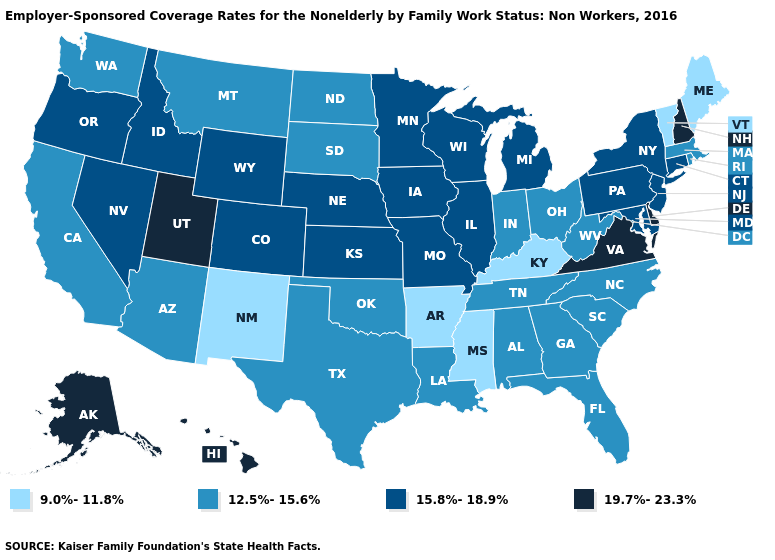Does Illinois have the same value as Wisconsin?
Keep it brief. Yes. Name the states that have a value in the range 12.5%-15.6%?
Write a very short answer. Alabama, Arizona, California, Florida, Georgia, Indiana, Louisiana, Massachusetts, Montana, North Carolina, North Dakota, Ohio, Oklahoma, Rhode Island, South Carolina, South Dakota, Tennessee, Texas, Washington, West Virginia. Name the states that have a value in the range 15.8%-18.9%?
Short answer required. Colorado, Connecticut, Idaho, Illinois, Iowa, Kansas, Maryland, Michigan, Minnesota, Missouri, Nebraska, Nevada, New Jersey, New York, Oregon, Pennsylvania, Wisconsin, Wyoming. Which states hav the highest value in the MidWest?
Give a very brief answer. Illinois, Iowa, Kansas, Michigan, Minnesota, Missouri, Nebraska, Wisconsin. What is the lowest value in the USA?
Quick response, please. 9.0%-11.8%. What is the value of Washington?
Short answer required. 12.5%-15.6%. Which states have the lowest value in the Northeast?
Answer briefly. Maine, Vermont. What is the value of North Carolina?
Be succinct. 12.5%-15.6%. Name the states that have a value in the range 9.0%-11.8%?
Give a very brief answer. Arkansas, Kentucky, Maine, Mississippi, New Mexico, Vermont. Among the states that border Nevada , does Utah have the highest value?
Write a very short answer. Yes. What is the lowest value in states that border Utah?
Write a very short answer. 9.0%-11.8%. Does the map have missing data?
Be succinct. No. What is the lowest value in the USA?
Concise answer only. 9.0%-11.8%. What is the value of Pennsylvania?
Short answer required. 15.8%-18.9%. Which states have the lowest value in the Northeast?
Answer briefly. Maine, Vermont. 